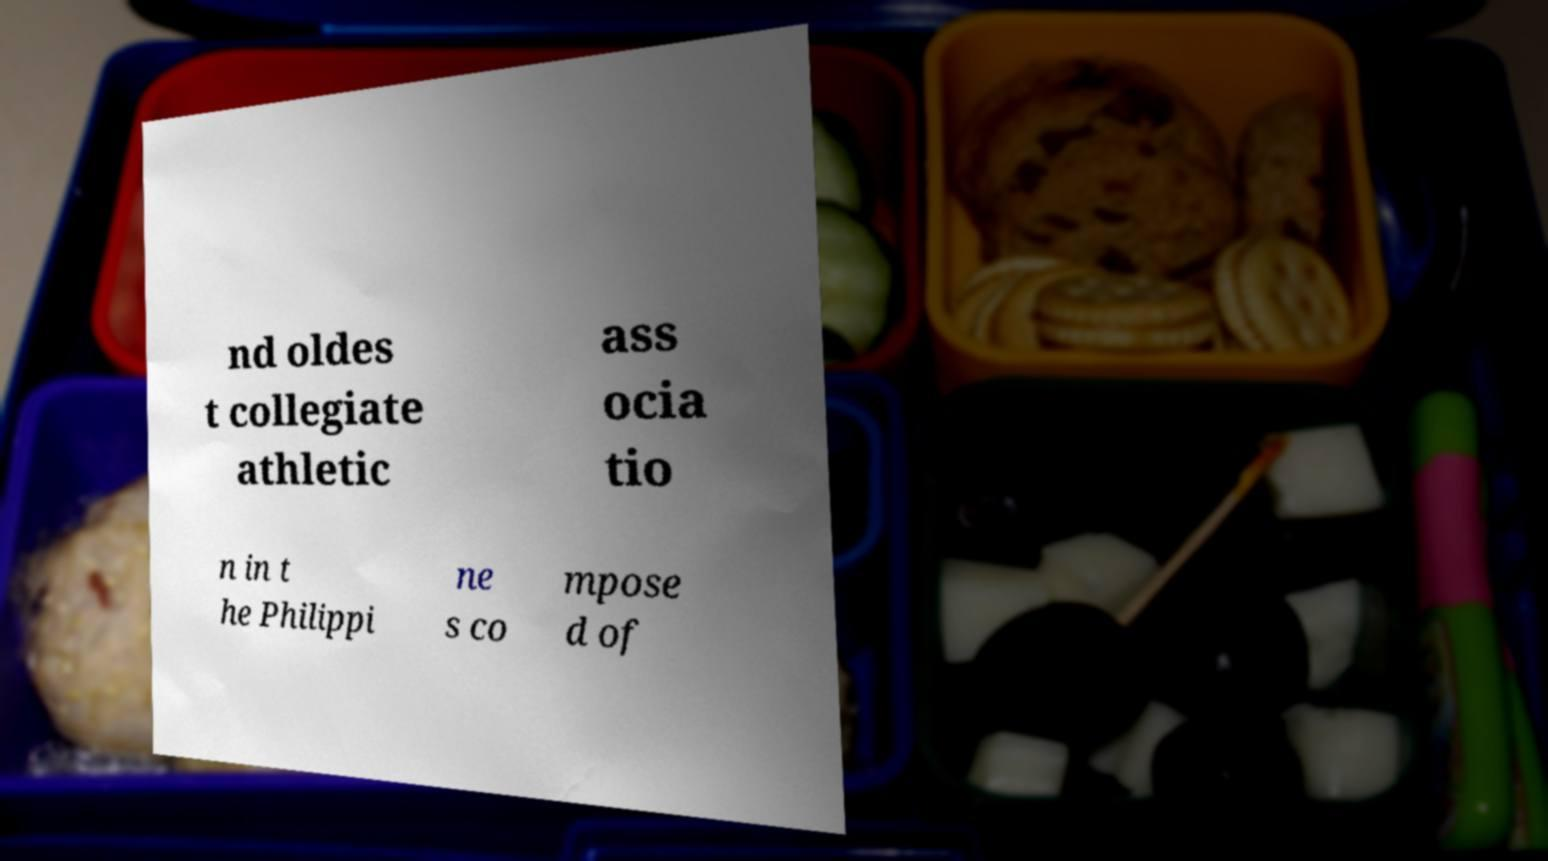Could you extract and type out the text from this image? nd oldes t collegiate athletic ass ocia tio n in t he Philippi ne s co mpose d of 